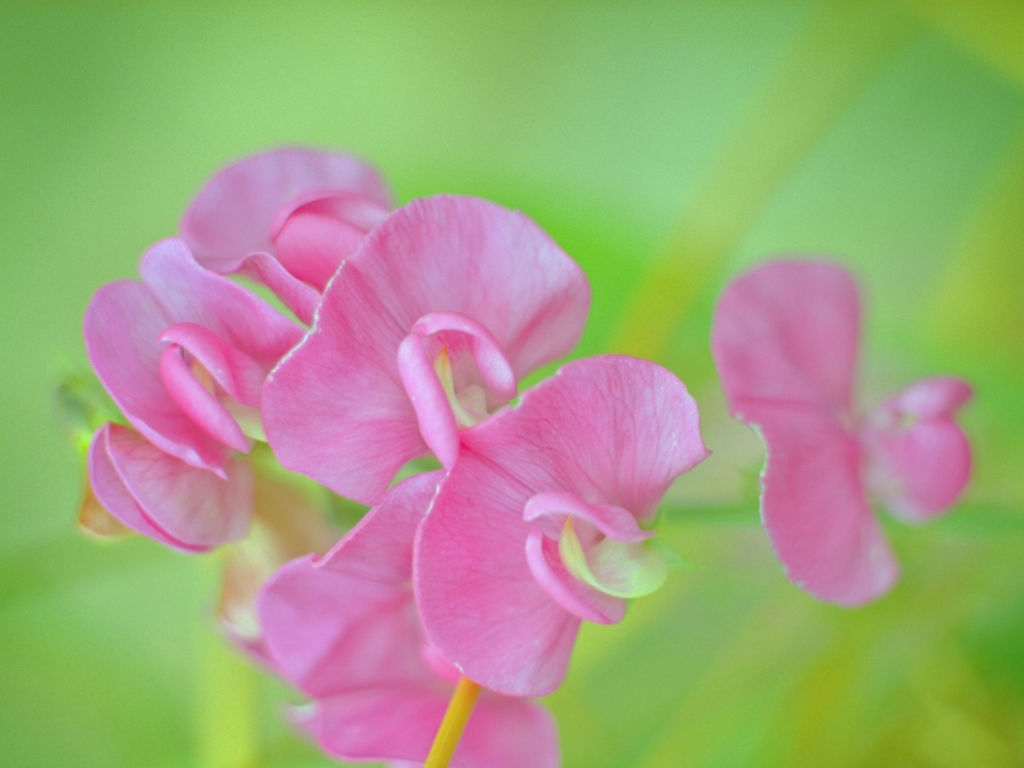What time of year is best for these flowers to bloom? Sweet peas typically flourish in the cooler months of early spring to the beginning of summer, depending on the local climate. They bloom best when they can grow in full sun before the heat of the summer takes hold. 